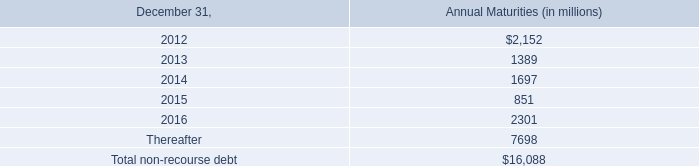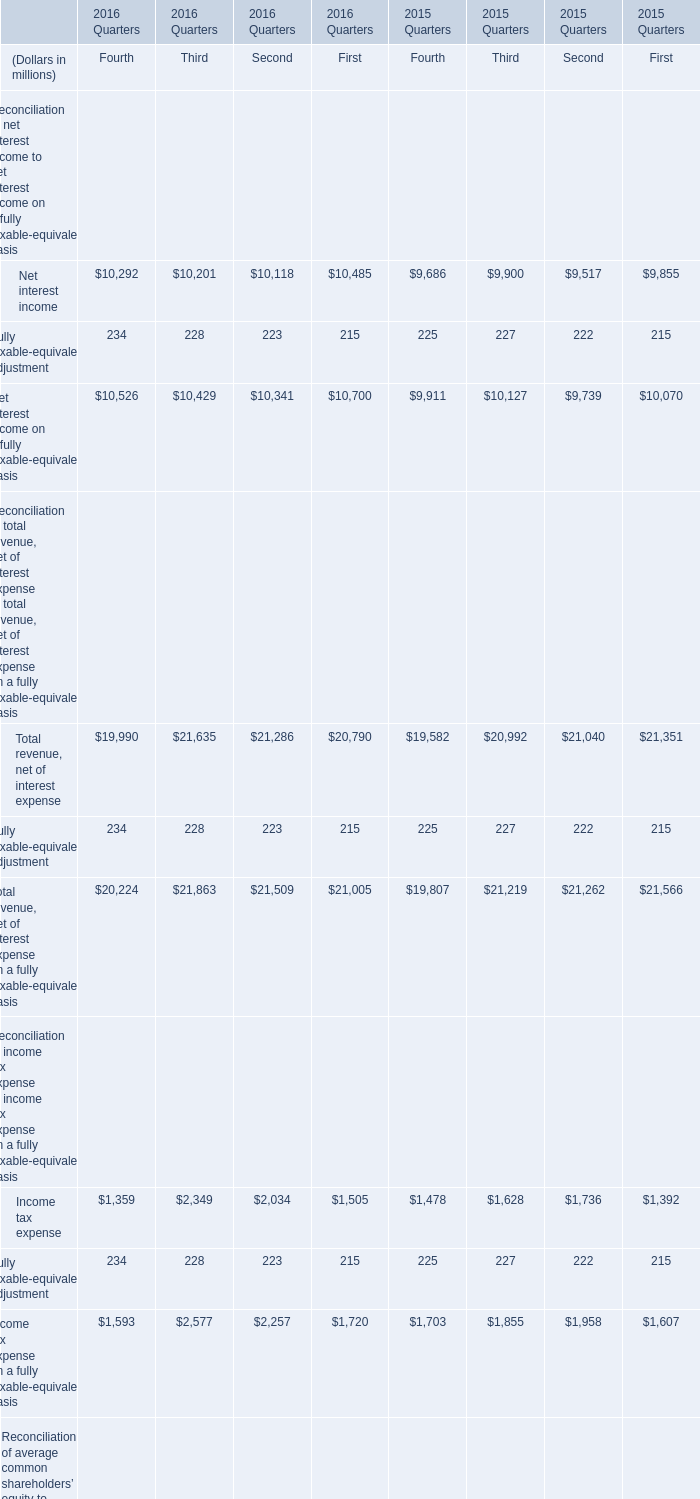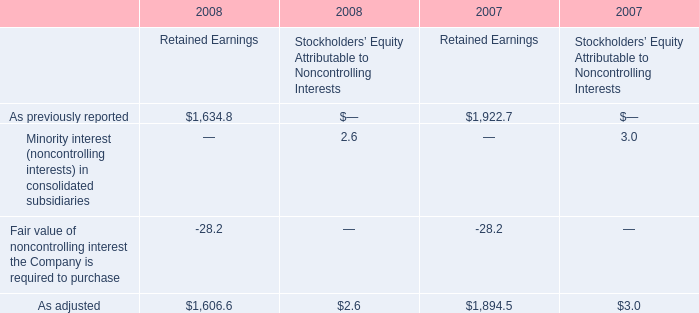What's the growth rate of Net interest income in Fourth Quarter, 2016? 
Computations: ((10292 - 10201) / 10201)
Answer: 0.00892. 